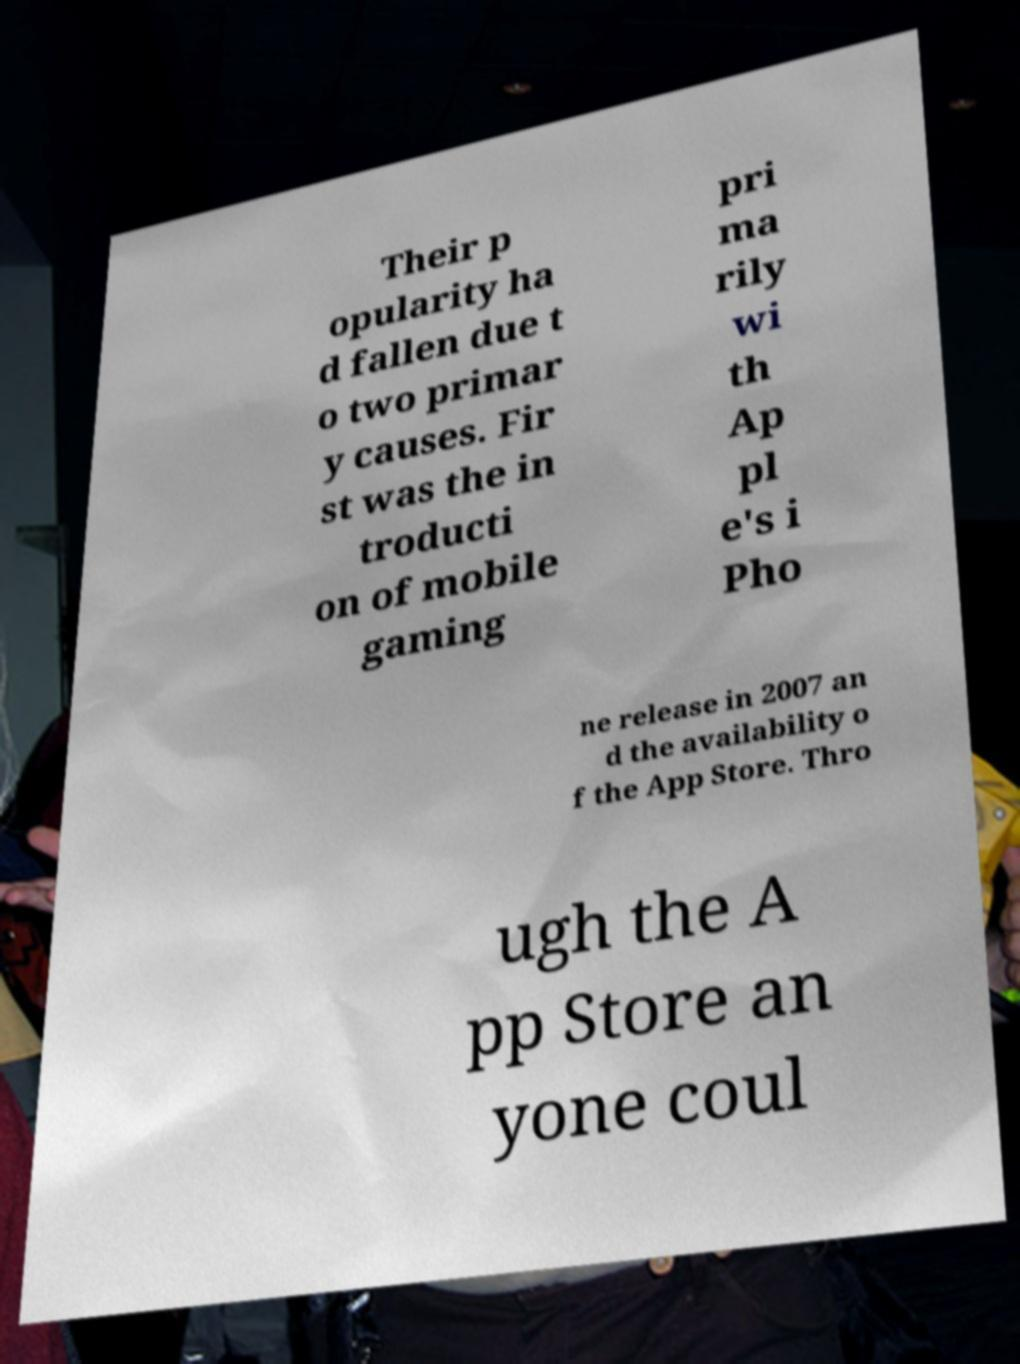There's text embedded in this image that I need extracted. Can you transcribe it verbatim? Their p opularity ha d fallen due t o two primar y causes. Fir st was the in troducti on of mobile gaming pri ma rily wi th Ap pl e's i Pho ne release in 2007 an d the availability o f the App Store. Thro ugh the A pp Store an yone coul 